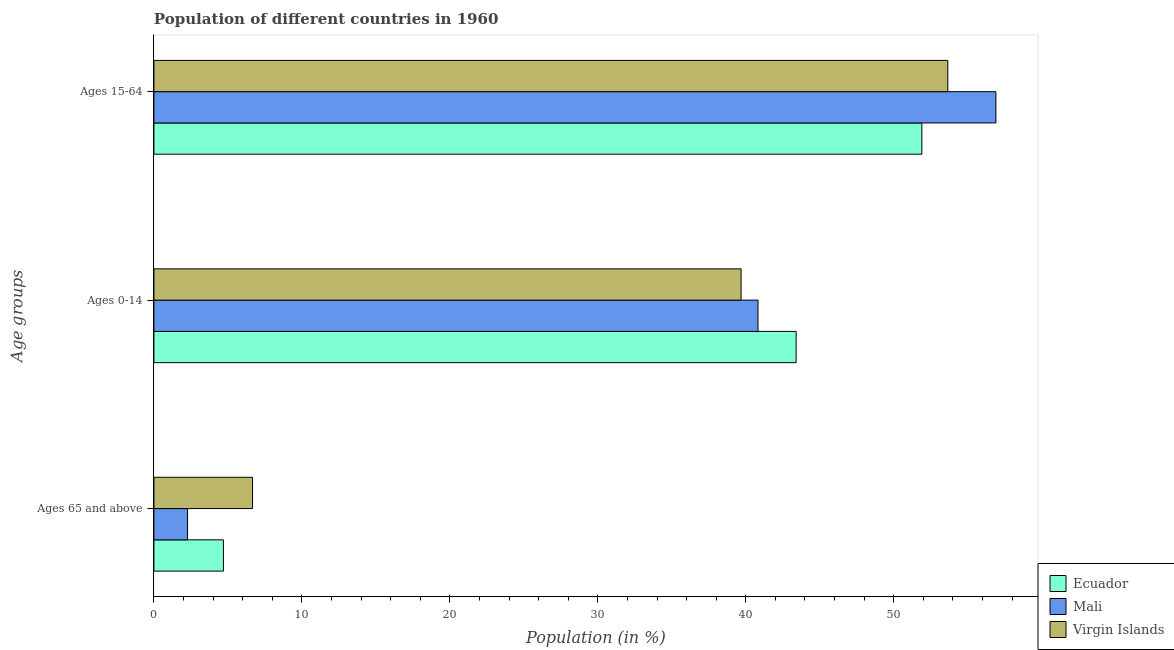How many different coloured bars are there?
Make the answer very short. 3. How many groups of bars are there?
Provide a short and direct response. 3. How many bars are there on the 2nd tick from the top?
Your answer should be compact. 3. How many bars are there on the 1st tick from the bottom?
Make the answer very short. 3. What is the label of the 3rd group of bars from the top?
Offer a terse response. Ages 65 and above. What is the percentage of population within the age-group of 65 and above in Mali?
Your response must be concise. 2.27. Across all countries, what is the maximum percentage of population within the age-group of 65 and above?
Offer a very short reply. 6.67. Across all countries, what is the minimum percentage of population within the age-group of 65 and above?
Offer a very short reply. 2.27. In which country was the percentage of population within the age-group 15-64 maximum?
Make the answer very short. Mali. In which country was the percentage of population within the age-group 0-14 minimum?
Your response must be concise. Virgin Islands. What is the total percentage of population within the age-group 0-14 in the graph?
Provide a succinct answer. 123.91. What is the difference between the percentage of population within the age-group 15-64 in Ecuador and that in Virgin Islands?
Provide a short and direct response. -1.75. What is the difference between the percentage of population within the age-group of 65 and above in Ecuador and the percentage of population within the age-group 0-14 in Mali?
Give a very brief answer. -36.13. What is the average percentage of population within the age-group 0-14 per country?
Provide a succinct answer. 41.3. What is the difference between the percentage of population within the age-group 0-14 and percentage of population within the age-group of 65 and above in Mali?
Your answer should be compact. 38.55. What is the ratio of the percentage of population within the age-group 0-14 in Mali to that in Virgin Islands?
Offer a terse response. 1.03. What is the difference between the highest and the second highest percentage of population within the age-group 0-14?
Offer a very short reply. 2.58. What is the difference between the highest and the lowest percentage of population within the age-group of 65 and above?
Make the answer very short. 4.39. In how many countries, is the percentage of population within the age-group 15-64 greater than the average percentage of population within the age-group 15-64 taken over all countries?
Your response must be concise. 1. Is the sum of the percentage of population within the age-group of 65 and above in Virgin Islands and Mali greater than the maximum percentage of population within the age-group 0-14 across all countries?
Keep it short and to the point. No. What does the 1st bar from the top in Ages 0-14 represents?
Make the answer very short. Virgin Islands. What does the 3rd bar from the bottom in Ages 15-64 represents?
Give a very brief answer. Virgin Islands. Is it the case that in every country, the sum of the percentage of population within the age-group of 65 and above and percentage of population within the age-group 0-14 is greater than the percentage of population within the age-group 15-64?
Your response must be concise. No. How many bars are there?
Provide a short and direct response. 9. Are all the bars in the graph horizontal?
Ensure brevity in your answer.  Yes. What is the difference between two consecutive major ticks on the X-axis?
Provide a succinct answer. 10. Does the graph contain any zero values?
Your response must be concise. No. Does the graph contain grids?
Give a very brief answer. No. How many legend labels are there?
Your answer should be compact. 3. How are the legend labels stacked?
Make the answer very short. Vertical. What is the title of the graph?
Offer a terse response. Population of different countries in 1960. What is the label or title of the Y-axis?
Provide a short and direct response. Age groups. What is the Population (in %) in Ecuador in Ages 65 and above?
Make the answer very short. 4.7. What is the Population (in %) of Mali in Ages 65 and above?
Provide a short and direct response. 2.27. What is the Population (in %) of Virgin Islands in Ages 65 and above?
Your answer should be very brief. 6.67. What is the Population (in %) of Ecuador in Ages 0-14?
Make the answer very short. 43.4. What is the Population (in %) in Mali in Ages 0-14?
Keep it short and to the point. 40.82. What is the Population (in %) of Virgin Islands in Ages 0-14?
Provide a short and direct response. 39.68. What is the Population (in %) of Ecuador in Ages 15-64?
Offer a terse response. 51.9. What is the Population (in %) of Mali in Ages 15-64?
Offer a terse response. 56.9. What is the Population (in %) in Virgin Islands in Ages 15-64?
Provide a short and direct response. 53.65. Across all Age groups, what is the maximum Population (in %) of Ecuador?
Give a very brief answer. 51.9. Across all Age groups, what is the maximum Population (in %) of Mali?
Provide a short and direct response. 56.9. Across all Age groups, what is the maximum Population (in %) of Virgin Islands?
Give a very brief answer. 53.65. Across all Age groups, what is the minimum Population (in %) in Ecuador?
Your answer should be very brief. 4.7. Across all Age groups, what is the minimum Population (in %) of Mali?
Offer a terse response. 2.27. Across all Age groups, what is the minimum Population (in %) in Virgin Islands?
Give a very brief answer. 6.67. What is the total Population (in %) of Ecuador in the graph?
Give a very brief answer. 100. What is the total Population (in %) in Virgin Islands in the graph?
Offer a terse response. 100. What is the difference between the Population (in %) in Ecuador in Ages 65 and above and that in Ages 0-14?
Make the answer very short. -38.71. What is the difference between the Population (in %) in Mali in Ages 65 and above and that in Ages 0-14?
Offer a terse response. -38.55. What is the difference between the Population (in %) in Virgin Islands in Ages 65 and above and that in Ages 0-14?
Make the answer very short. -33.02. What is the difference between the Population (in %) of Ecuador in Ages 65 and above and that in Ages 15-64?
Make the answer very short. -47.2. What is the difference between the Population (in %) of Mali in Ages 65 and above and that in Ages 15-64?
Offer a terse response. -54.63. What is the difference between the Population (in %) of Virgin Islands in Ages 65 and above and that in Ages 15-64?
Provide a short and direct response. -46.99. What is the difference between the Population (in %) of Ecuador in Ages 0-14 and that in Ages 15-64?
Your answer should be very brief. -8.5. What is the difference between the Population (in %) of Mali in Ages 0-14 and that in Ages 15-64?
Keep it short and to the point. -16.08. What is the difference between the Population (in %) of Virgin Islands in Ages 0-14 and that in Ages 15-64?
Your response must be concise. -13.97. What is the difference between the Population (in %) in Ecuador in Ages 65 and above and the Population (in %) in Mali in Ages 0-14?
Keep it short and to the point. -36.13. What is the difference between the Population (in %) in Ecuador in Ages 65 and above and the Population (in %) in Virgin Islands in Ages 0-14?
Make the answer very short. -34.98. What is the difference between the Population (in %) in Mali in Ages 65 and above and the Population (in %) in Virgin Islands in Ages 0-14?
Ensure brevity in your answer.  -37.41. What is the difference between the Population (in %) in Ecuador in Ages 65 and above and the Population (in %) in Mali in Ages 15-64?
Offer a terse response. -52.21. What is the difference between the Population (in %) of Ecuador in Ages 65 and above and the Population (in %) of Virgin Islands in Ages 15-64?
Offer a terse response. -48.96. What is the difference between the Population (in %) of Mali in Ages 65 and above and the Population (in %) of Virgin Islands in Ages 15-64?
Offer a terse response. -51.38. What is the difference between the Population (in %) in Ecuador in Ages 0-14 and the Population (in %) in Mali in Ages 15-64?
Make the answer very short. -13.5. What is the difference between the Population (in %) in Ecuador in Ages 0-14 and the Population (in %) in Virgin Islands in Ages 15-64?
Ensure brevity in your answer.  -10.25. What is the difference between the Population (in %) of Mali in Ages 0-14 and the Population (in %) of Virgin Islands in Ages 15-64?
Your answer should be very brief. -12.83. What is the average Population (in %) in Ecuador per Age groups?
Provide a succinct answer. 33.33. What is the average Population (in %) in Mali per Age groups?
Keep it short and to the point. 33.33. What is the average Population (in %) of Virgin Islands per Age groups?
Offer a terse response. 33.33. What is the difference between the Population (in %) of Ecuador and Population (in %) of Mali in Ages 65 and above?
Provide a succinct answer. 2.43. What is the difference between the Population (in %) of Ecuador and Population (in %) of Virgin Islands in Ages 65 and above?
Your response must be concise. -1.97. What is the difference between the Population (in %) in Mali and Population (in %) in Virgin Islands in Ages 65 and above?
Your response must be concise. -4.39. What is the difference between the Population (in %) of Ecuador and Population (in %) of Mali in Ages 0-14?
Your response must be concise. 2.58. What is the difference between the Population (in %) in Ecuador and Population (in %) in Virgin Islands in Ages 0-14?
Give a very brief answer. 3.72. What is the difference between the Population (in %) of Mali and Population (in %) of Virgin Islands in Ages 0-14?
Offer a terse response. 1.14. What is the difference between the Population (in %) of Ecuador and Population (in %) of Mali in Ages 15-64?
Offer a terse response. -5. What is the difference between the Population (in %) in Ecuador and Population (in %) in Virgin Islands in Ages 15-64?
Keep it short and to the point. -1.75. What is the difference between the Population (in %) in Mali and Population (in %) in Virgin Islands in Ages 15-64?
Offer a very short reply. 3.25. What is the ratio of the Population (in %) of Ecuador in Ages 65 and above to that in Ages 0-14?
Offer a very short reply. 0.11. What is the ratio of the Population (in %) in Mali in Ages 65 and above to that in Ages 0-14?
Your answer should be very brief. 0.06. What is the ratio of the Population (in %) of Virgin Islands in Ages 65 and above to that in Ages 0-14?
Provide a succinct answer. 0.17. What is the ratio of the Population (in %) of Ecuador in Ages 65 and above to that in Ages 15-64?
Provide a succinct answer. 0.09. What is the ratio of the Population (in %) of Mali in Ages 65 and above to that in Ages 15-64?
Offer a terse response. 0.04. What is the ratio of the Population (in %) of Virgin Islands in Ages 65 and above to that in Ages 15-64?
Offer a very short reply. 0.12. What is the ratio of the Population (in %) in Ecuador in Ages 0-14 to that in Ages 15-64?
Offer a very short reply. 0.84. What is the ratio of the Population (in %) in Mali in Ages 0-14 to that in Ages 15-64?
Give a very brief answer. 0.72. What is the ratio of the Population (in %) in Virgin Islands in Ages 0-14 to that in Ages 15-64?
Your response must be concise. 0.74. What is the difference between the highest and the second highest Population (in %) of Ecuador?
Offer a terse response. 8.5. What is the difference between the highest and the second highest Population (in %) of Mali?
Your response must be concise. 16.08. What is the difference between the highest and the second highest Population (in %) in Virgin Islands?
Give a very brief answer. 13.97. What is the difference between the highest and the lowest Population (in %) of Ecuador?
Provide a succinct answer. 47.2. What is the difference between the highest and the lowest Population (in %) of Mali?
Provide a short and direct response. 54.63. What is the difference between the highest and the lowest Population (in %) of Virgin Islands?
Offer a terse response. 46.99. 